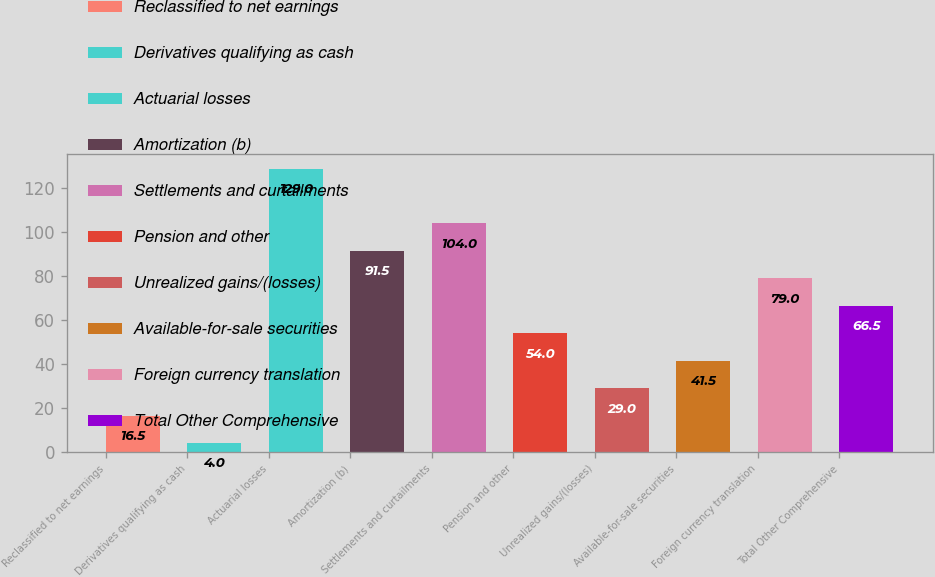<chart> <loc_0><loc_0><loc_500><loc_500><bar_chart><fcel>Reclassified to net earnings<fcel>Derivatives qualifying as cash<fcel>Actuarial losses<fcel>Amortization (b)<fcel>Settlements and curtailments<fcel>Pension and other<fcel>Unrealized gains/(losses)<fcel>Available-for-sale securities<fcel>Foreign currency translation<fcel>Total Other Comprehensive<nl><fcel>16.5<fcel>4<fcel>129<fcel>91.5<fcel>104<fcel>54<fcel>29<fcel>41.5<fcel>79<fcel>66.5<nl></chart> 